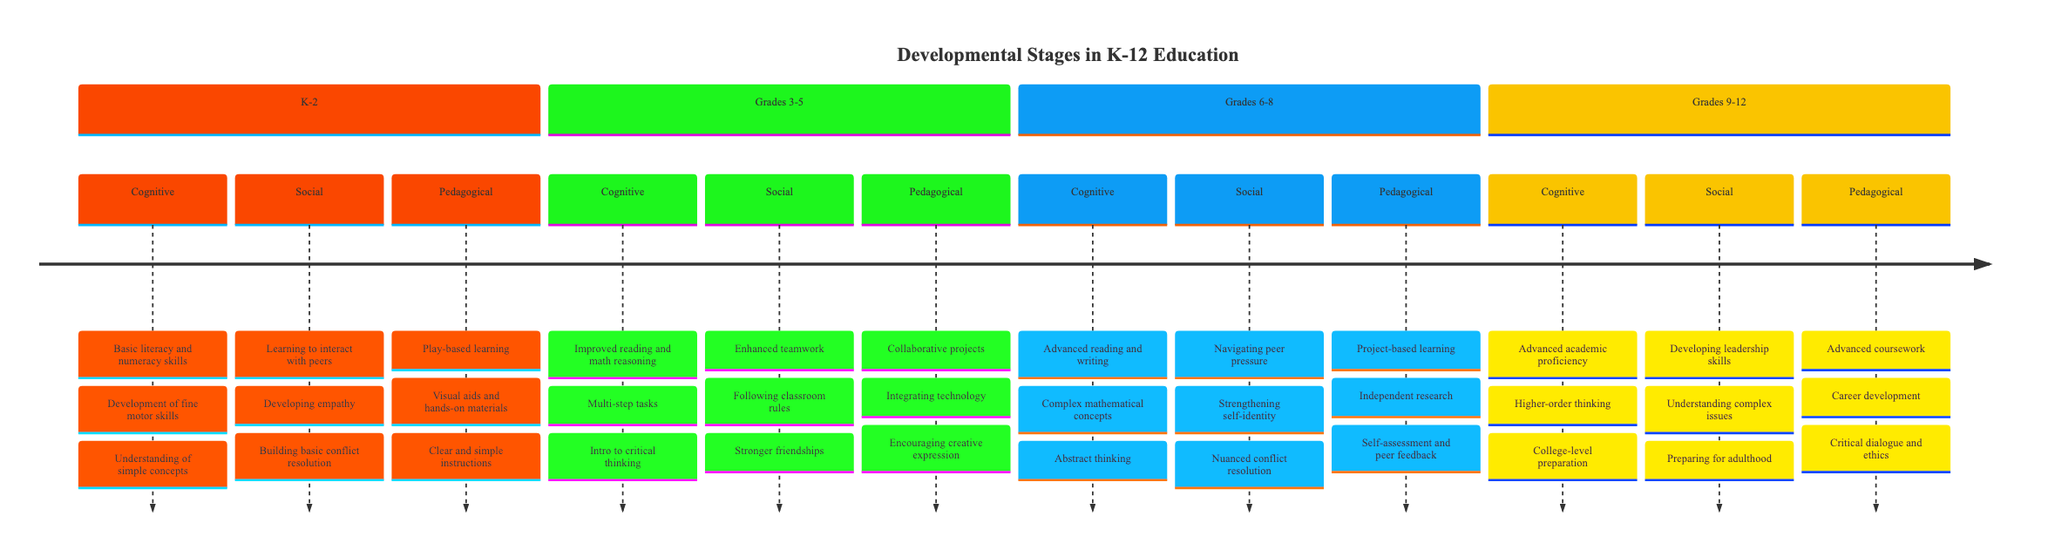What are the cognitive milestones in Grades 3-5? The diagram lists three cognitive milestones for Grades 3-5: improved reading comprehension and mathematical reasoning, ability to complete multi-step tasks, and introduction to critical thinking and problem-solving.
Answer: improved reading comprehension and mathematical reasoning, ability to complete multi-step tasks, introduction to critical thinking and problem-solving How many pedagogical strategies are listed for K-2? The diagram specifies three pedagogical strategies for K-2: incorporating play-based learning activities, using visual aids and hands-on materials, and providing clear and simple instructions and feedback. Therefore, the total count is three.
Answer: 3 What is a social milestone for Grades 6-8? From the diagram, one of the social milestones specified for Grades 6-8 is navigating complex social dynamics and peer pressure. This is one among the three listed.
Answer: navigating complex social dynamics and peer pressure What pedagogical strategy involves technology in Grades 3-5? The pedagogical strategy that involves technology for Grades 3-5 is integrating technology to support learning. This is clearly indicated as one of the three strategies in the section for this grade.
Answer: integrating technology to support learning How do cognitive milestones in K-2 compare with those in Grades 9-12 in terms of complexity? The cognitive milestones in K-2 are basic skills such as literacy and numeracy, while those in Grades 9-12 involve proficiency in advanced academic disciplines and readiness for higher-order thinking. This indicates a progression in complexity as students advance through grades.
Answer: basic skills vs. advanced academic proficiency What is the first cognitive milestone listed for Grades 6-8? The first cognitive milestone listed for Grades 6-8 in the diagram is advanced reading and writing capabilities, which sets the foundation for the other milestones that follow.
Answer: advanced reading and writing capabilities 